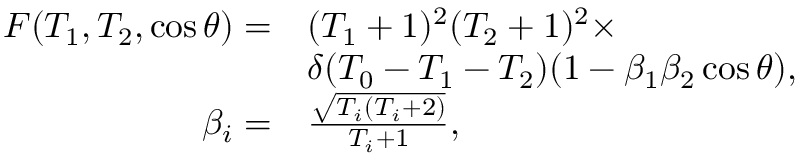Convert formula to latex. <formula><loc_0><loc_0><loc_500><loc_500>\begin{array} { r l } { F ( T _ { 1 } , T _ { 2 } , \cos { \theta } ) = } & { ( T _ { 1 } + 1 ) ^ { 2 } ( T _ { 2 } + 1 ) ^ { 2 } \times } \\ & { \delta ( T _ { 0 } - T _ { 1 } - T _ { 2 } ) ( 1 - \beta _ { 1 } \beta _ { 2 } \cos { \theta } ) , } \\ { \beta _ { i } = } & { \frac { \sqrt { T _ { i } ( T _ { i } + 2 ) } } { T _ { i } + 1 } , } \end{array}</formula> 